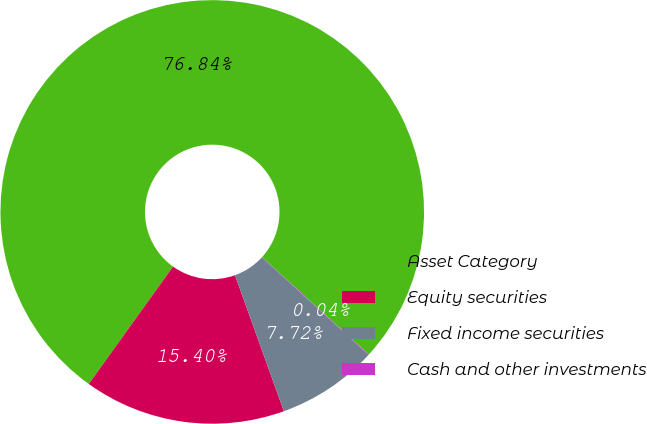Convert chart. <chart><loc_0><loc_0><loc_500><loc_500><pie_chart><fcel>Asset Category<fcel>Equity securities<fcel>Fixed income securities<fcel>Cash and other investments<nl><fcel>76.84%<fcel>15.4%<fcel>7.72%<fcel>0.04%<nl></chart> 